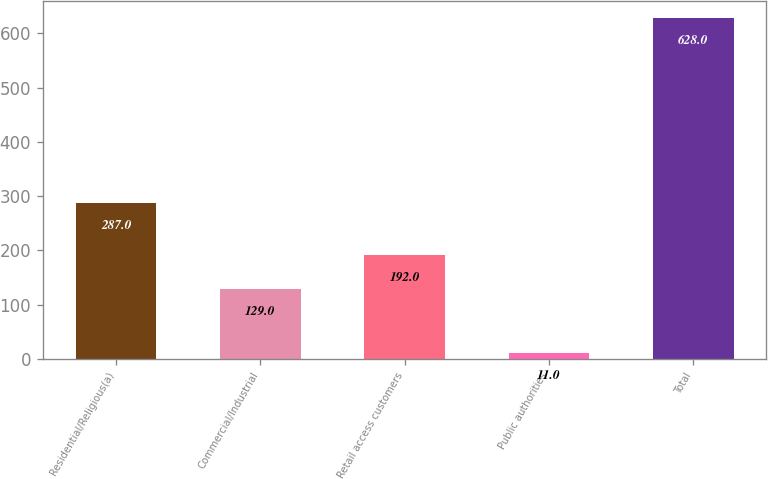<chart> <loc_0><loc_0><loc_500><loc_500><bar_chart><fcel>Residential/Religious(a)<fcel>Commercial/Industrial<fcel>Retail access customers<fcel>Public authorities<fcel>Total<nl><fcel>287<fcel>129<fcel>192<fcel>11<fcel>628<nl></chart> 